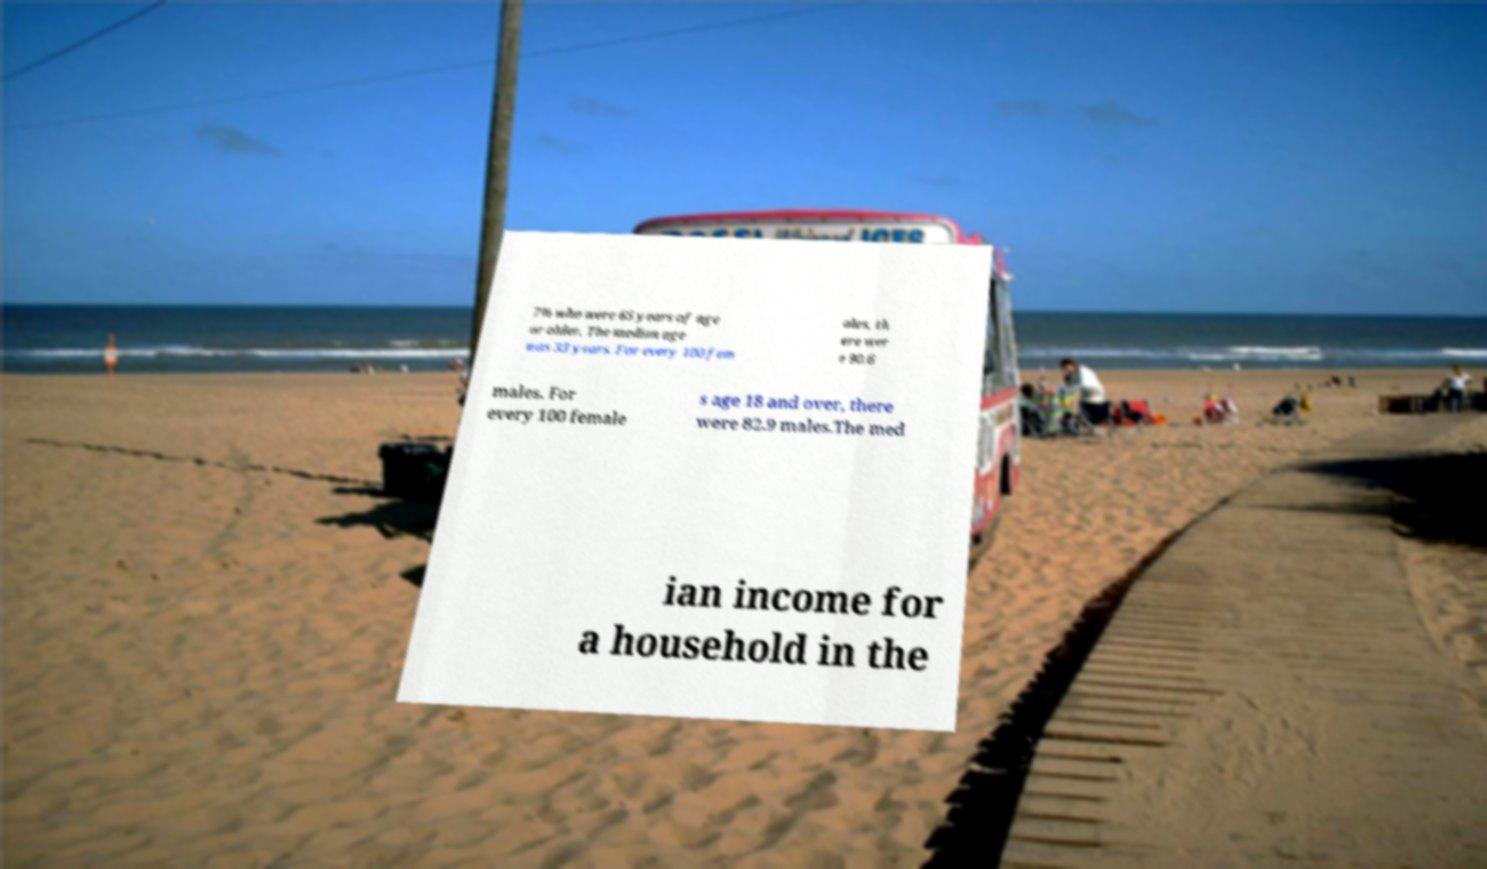For documentation purposes, I need the text within this image transcribed. Could you provide that? 7% who were 65 years of age or older. The median age was 33 years. For every 100 fem ales, th ere wer e 90.6 males. For every 100 female s age 18 and over, there were 82.9 males.The med ian income for a household in the 